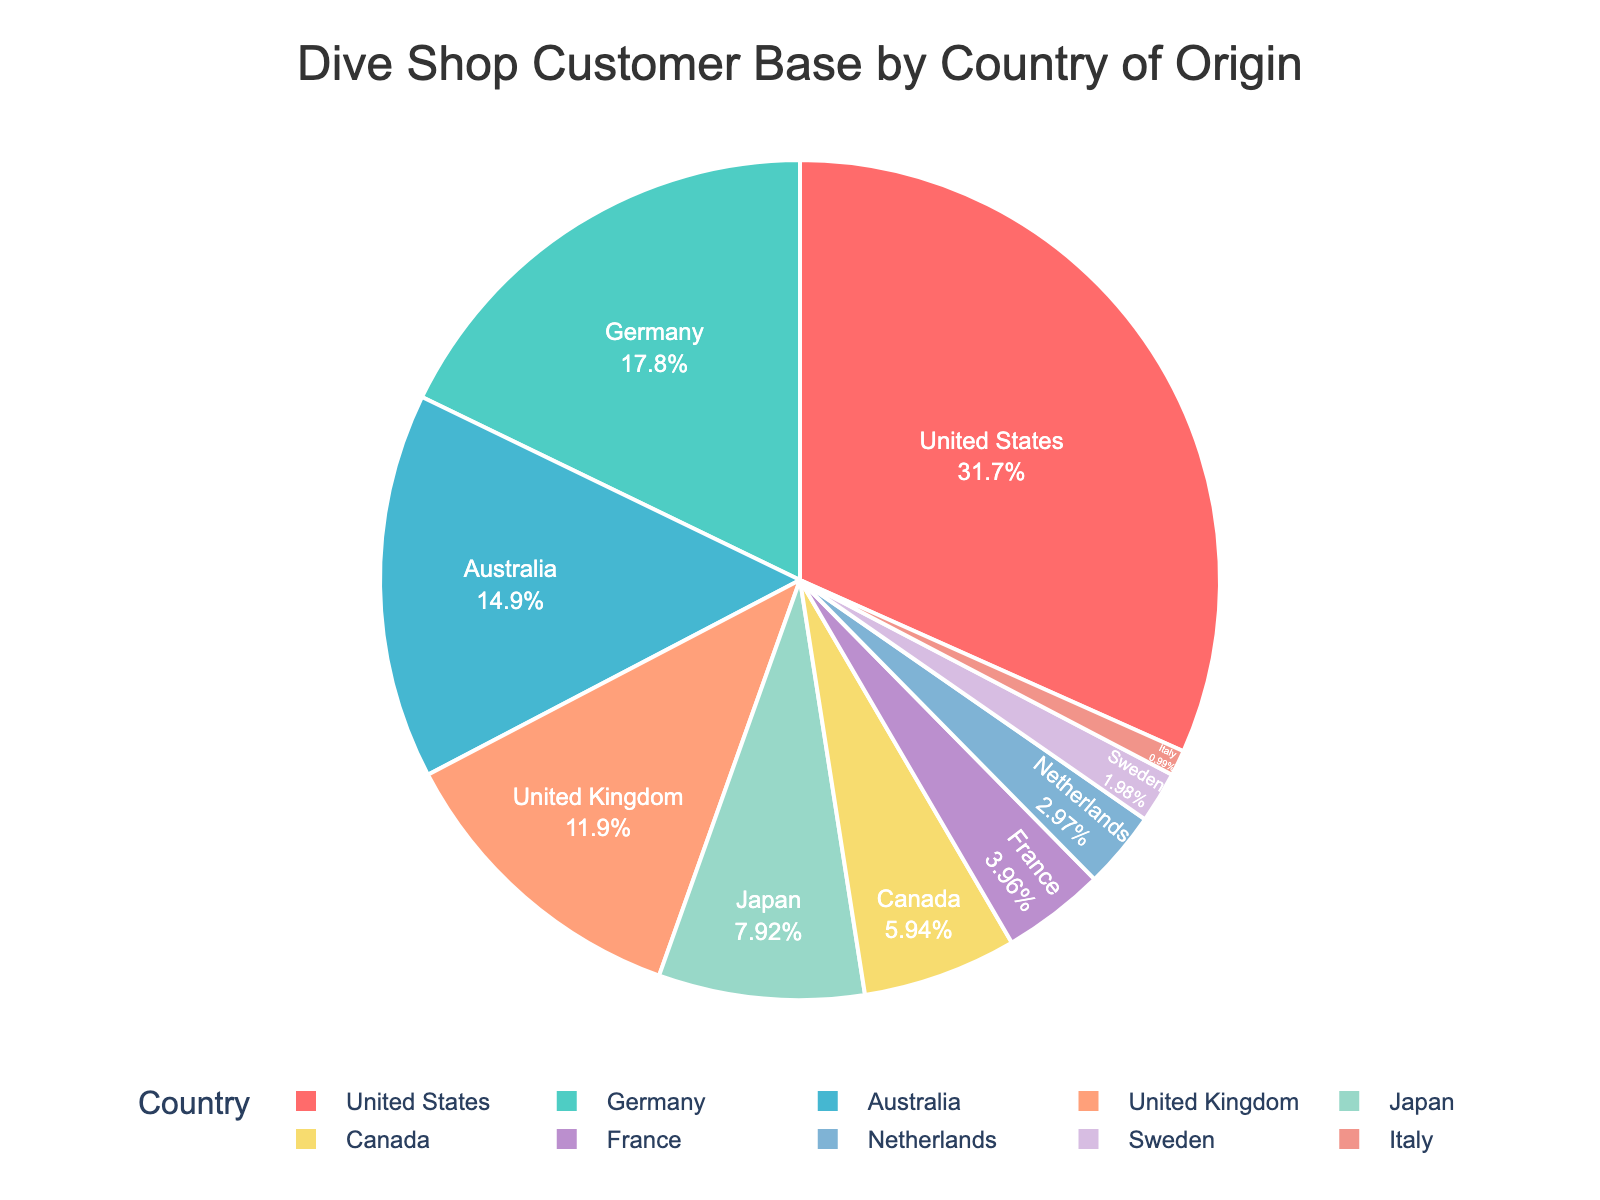Which country has the highest percentage of customers in the dive shop? The pie chart's largest segment visually represents the United States, which has a 32% customer base share.
Answer: United States What is the combined percentage of customers from Germany and Australia? The percentage of customers from Germany is 18%, and from Australia, it is 15%. Adding these two values, 18% + 15% = 33%.
Answer: 33% Which countries have a customer percentage less than that of Japan? Japan's customer percentage is 8%. Countries with lower percentages are Canada (6%), France (4%), Netherlands (3%), Sweden (2%), and Italy (1%).
Answer: Canada, France, Netherlands, Sweden, Italy What is the difference in customer base percentage between the United States and the United Kingdom? The United States has 32% while the United Kingdom has 12%. The difference is 32% - 12% = 20%.
Answer: 20% How many countries have a customer base equal to or greater than 10%? The chart shows that the United States (32%), Germany (18%), Australia (15%), and the United Kingdom (12%) have percentages equal to or greater than 10%. This totals four countries.
Answer: 4 What is the smallest percentage on the chart, and which country does it represent? Observing the pie chart, the smallest segment is 1%, which represents Italy.
Answer: Italy Compare the total percentage of customers from France and Sweden to that of Canada. Which has the higher percentage? France has 4% and Sweden has 2%, summing up to 6%. Canada also has 6%. Hence, they have the same percentage.
Answer: Same Which color represents customers from the Netherlands in the pie chart? The Netherlands is one of the smaller segments near the end of the list. It is represented by the color near the bottom of the legend, which is blue.
Answer: Blue What percentage of the customer base does the sum of the Japanese, Canadian, and French customers represent? Adding the percentages for Japan (8%), Canada (6%), and France (4%), we get 8% + 6% + 4% = 18%.
Answer: 18% Among the countries listed, which country has a customer base 3 times that of Sweden? Sweden has 2%. Germany has 18%, which is 3 times 6% (2% * 3 = 6%).
Answer: Germany 